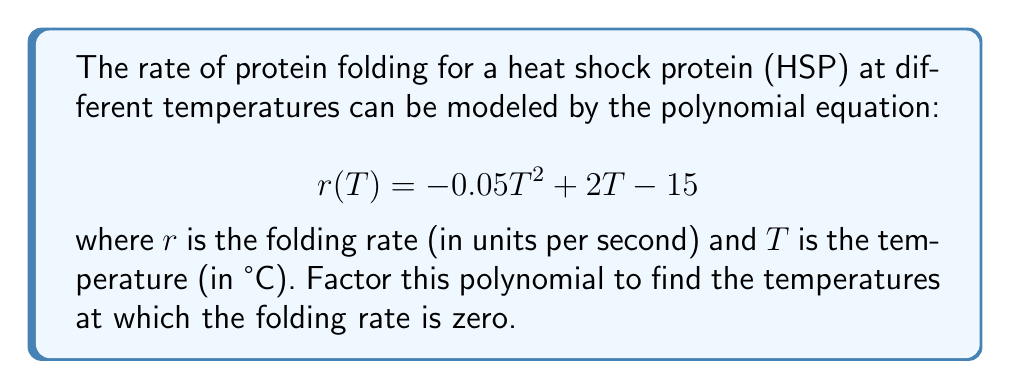Teach me how to tackle this problem. To factor this polynomial, we'll follow these steps:

1) First, we recognize this as a quadratic equation in the standard form $ax^2 + bx + c$, where:
   $a = -0.05$, $b = 2$, and $c = -15$

2) To factor this, we'll use the quadratic formula: $x = \frac{-b \pm \sqrt{b^2 - 4ac}}{2a}$

3) Let's substitute our values:
   $$ T = \frac{-2 \pm \sqrt{2^2 - 4(-0.05)(-15)}}{2(-0.05)} $$

4) Simplify under the square root:
   $$ T = \frac{-2 \pm \sqrt{4 - 3}}{-0.1} = \frac{-2 \pm \sqrt{1}}{-0.1} = \frac{-2 \pm 1}{-0.1} $$

5) This gives us two solutions:
   $$ T_1 = \frac{-2 + 1}{-0.1} = \frac{-1}{-0.1} = 10 $$
   $$ T_2 = \frac{-2 - 1}{-0.1} = \frac{-3}{-0.1} = 30 $$

6) Now we can factor the original polynomial:
   $$ r(T) = -0.05(T - 10)(T - 30) $$

This factored form shows that the folding rate is zero when $T = 10°C$ or $T = 30°C$.
Answer: $$ r(T) = -0.05(T - 10)(T - 30) $$ 